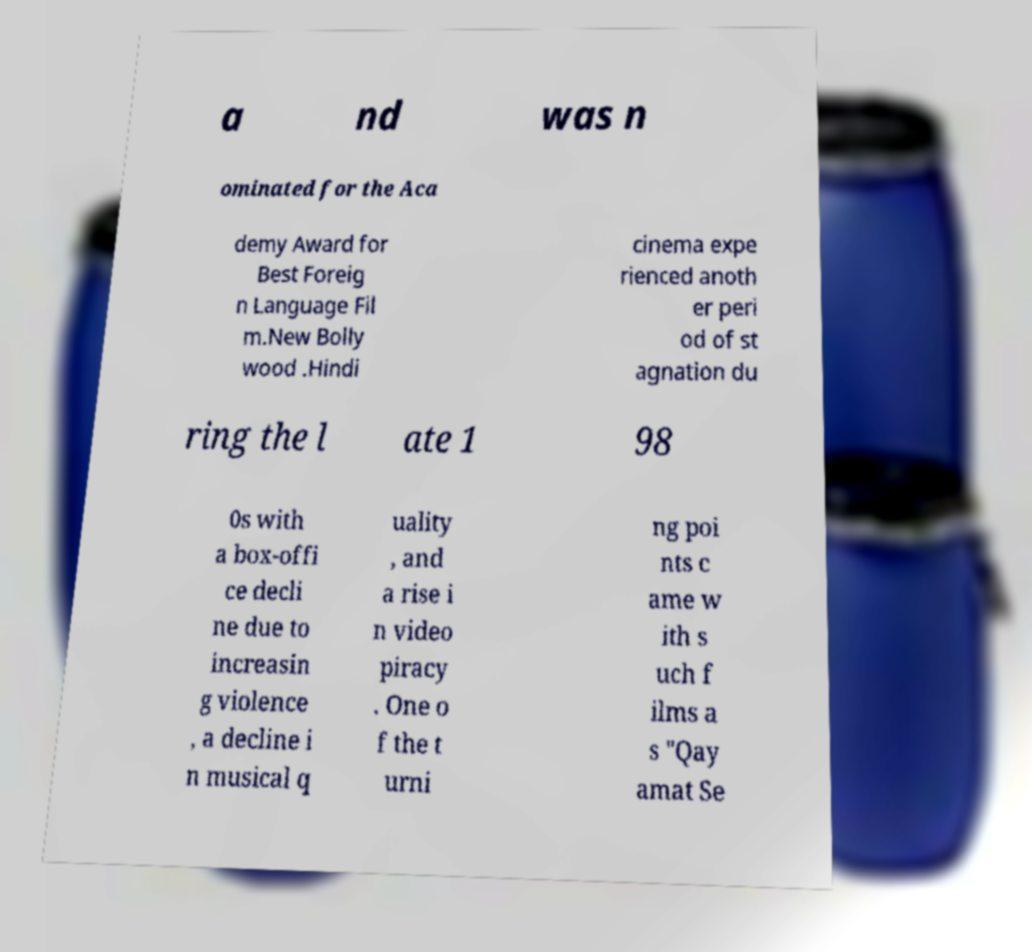Please read and relay the text visible in this image. What does it say? a nd was n ominated for the Aca demy Award for Best Foreig n Language Fil m.New Bolly wood .Hindi cinema expe rienced anoth er peri od of st agnation du ring the l ate 1 98 0s with a box-offi ce decli ne due to increasin g violence , a decline i n musical q uality , and a rise i n video piracy . One o f the t urni ng poi nts c ame w ith s uch f ilms a s "Qay amat Se 